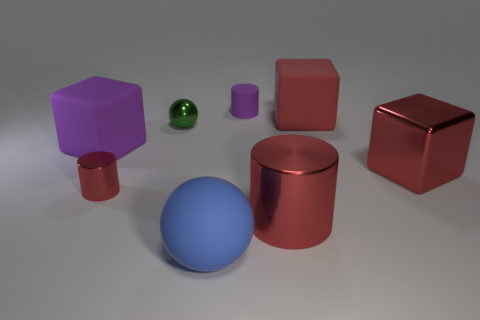What is the color of the cylinder that is the same size as the blue rubber thing? The color of the cylinder that matches the size of the blue sphere is red. It shares the same width and height, which suggests they are of comparable size. 